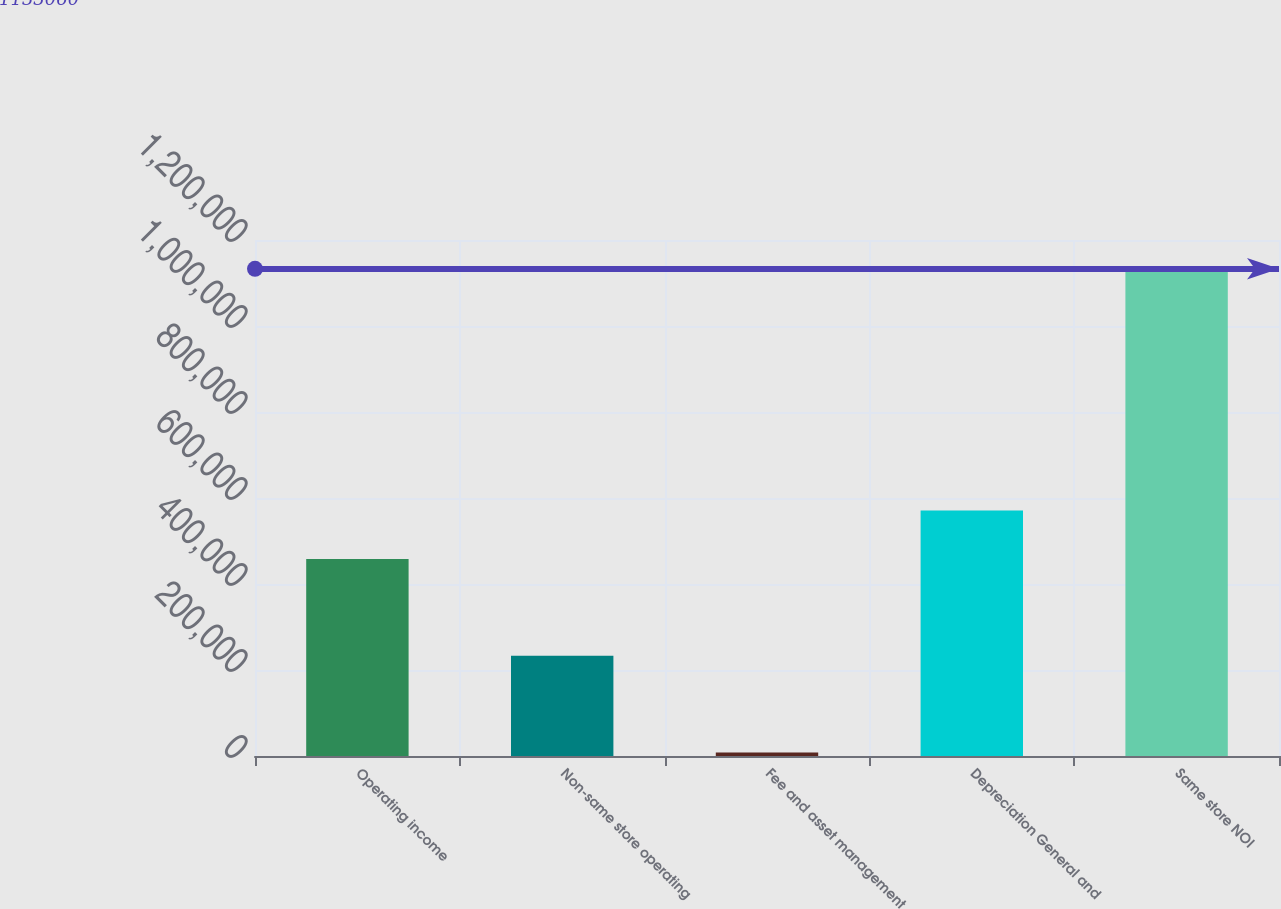Convert chart. <chart><loc_0><loc_0><loc_500><loc_500><bar_chart><fcel>Operating income<fcel>Non-same store operating<fcel>Fee and asset management<fcel>Depreciation General and<fcel>Same store NOI<nl><fcel>458158<fcel>232997<fcel>7981<fcel>570666<fcel>1.13306e+06<nl></chart> 